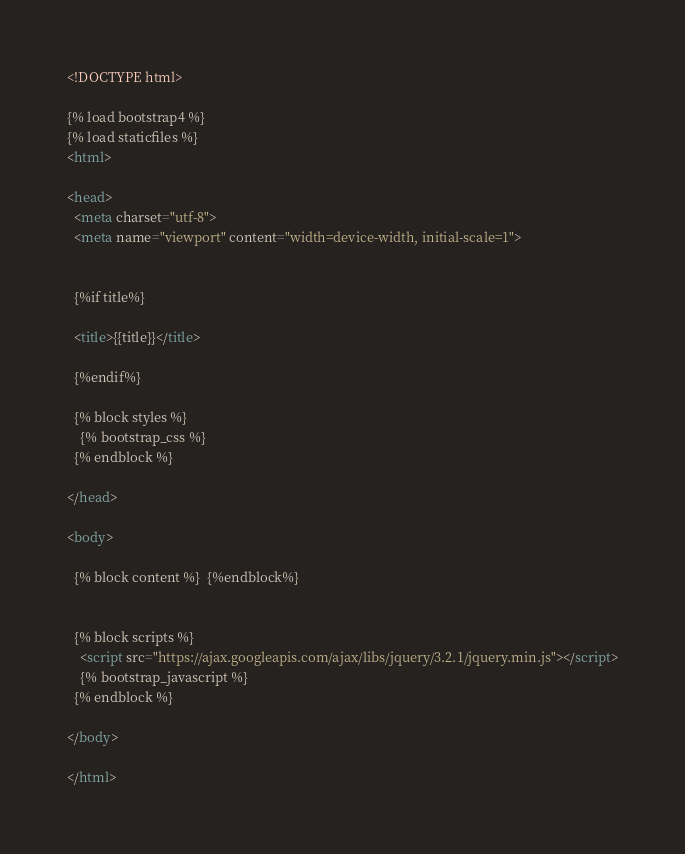Convert code to text. <code><loc_0><loc_0><loc_500><loc_500><_HTML_><!DOCTYPE html>

{% load bootstrap4 %}
{% load staticfiles %}
<html>

<head>
  <meta charset="utf-8">
  <meta name="viewport" content="width=device-width, initial-scale=1">


  {%if title%}

  <title>{{title}}</title>

  {%endif%}

  {% block styles %}
    {% bootstrap_css %}
  {% endblock %}

</head>

<body>

  {% block content %}  {%endblock%}


  {% block scripts %}
    <script src="https://ajax.googleapis.com/ajax/libs/jquery/3.2.1/jquery.min.js"></script>
    {% bootstrap_javascript %}
  {% endblock %}

</body>

</html></code> 